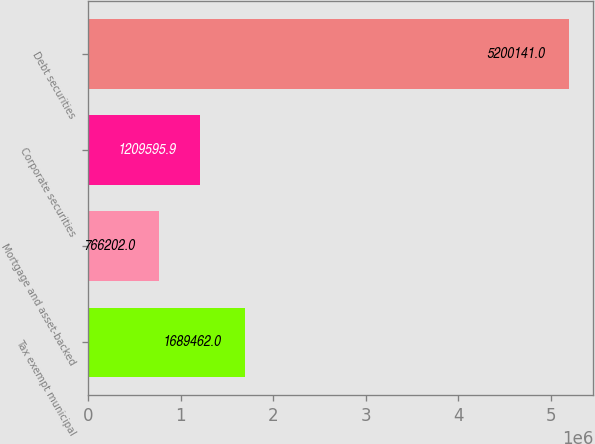Convert chart to OTSL. <chart><loc_0><loc_0><loc_500><loc_500><bar_chart><fcel>Tax exempt municipal<fcel>Mortgage and asset-backed<fcel>Corporate securities<fcel>Debt securities<nl><fcel>1.68946e+06<fcel>766202<fcel>1.2096e+06<fcel>5.20014e+06<nl></chart> 